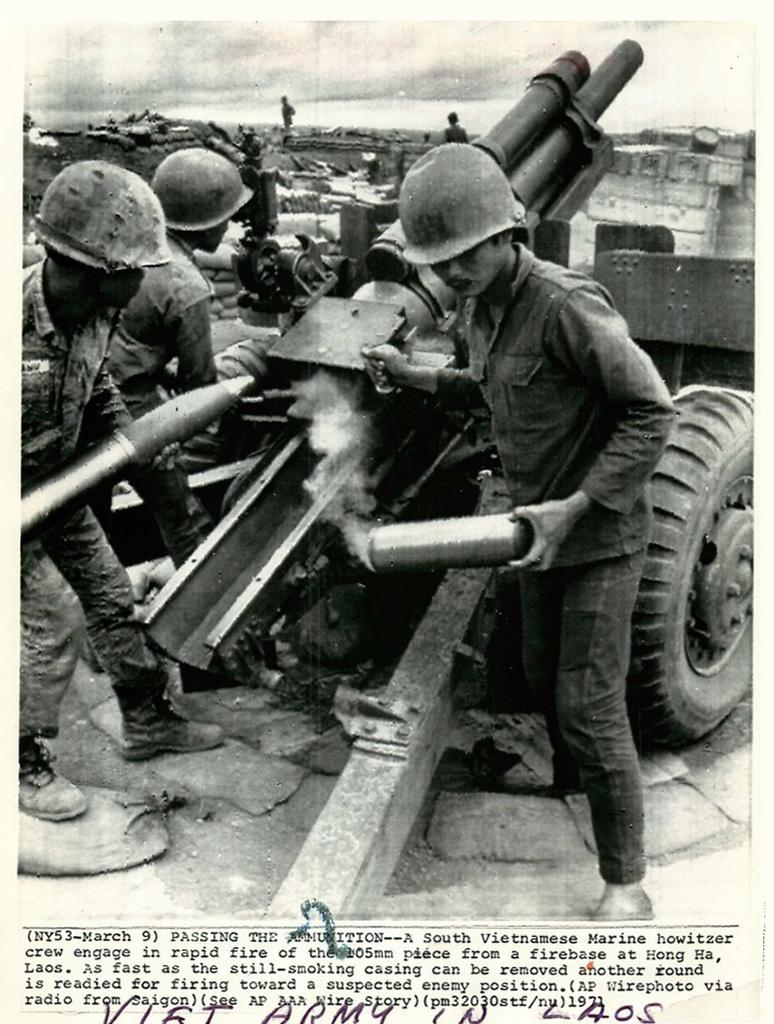What type of visual representation is shown in the image? The image is a poster. Who or what can be seen in the poster? There are persons and a vehicle in the image. Is there any text present in the poster? Yes, there is text in the image. Can you see any steam coming from the vehicle in the image? There is no steam visible in the image. What type of net is being used by the persons in the image? There is no net present in the image. 